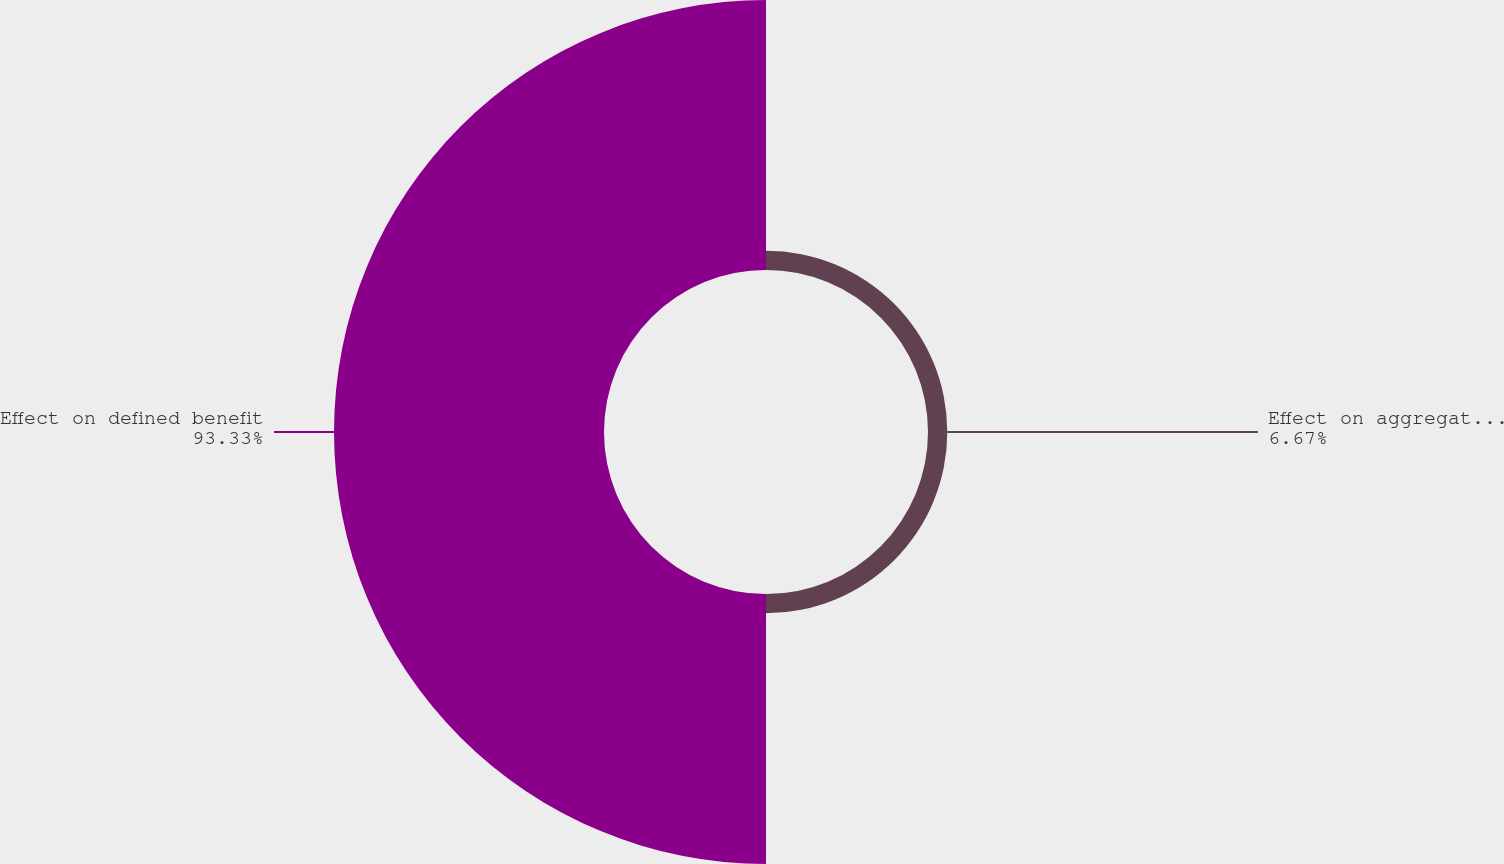Convert chart to OTSL. <chart><loc_0><loc_0><loc_500><loc_500><pie_chart><fcel>Effect on aggregate service<fcel>Effect on defined benefit<nl><fcel>6.67%<fcel>93.33%<nl></chart> 